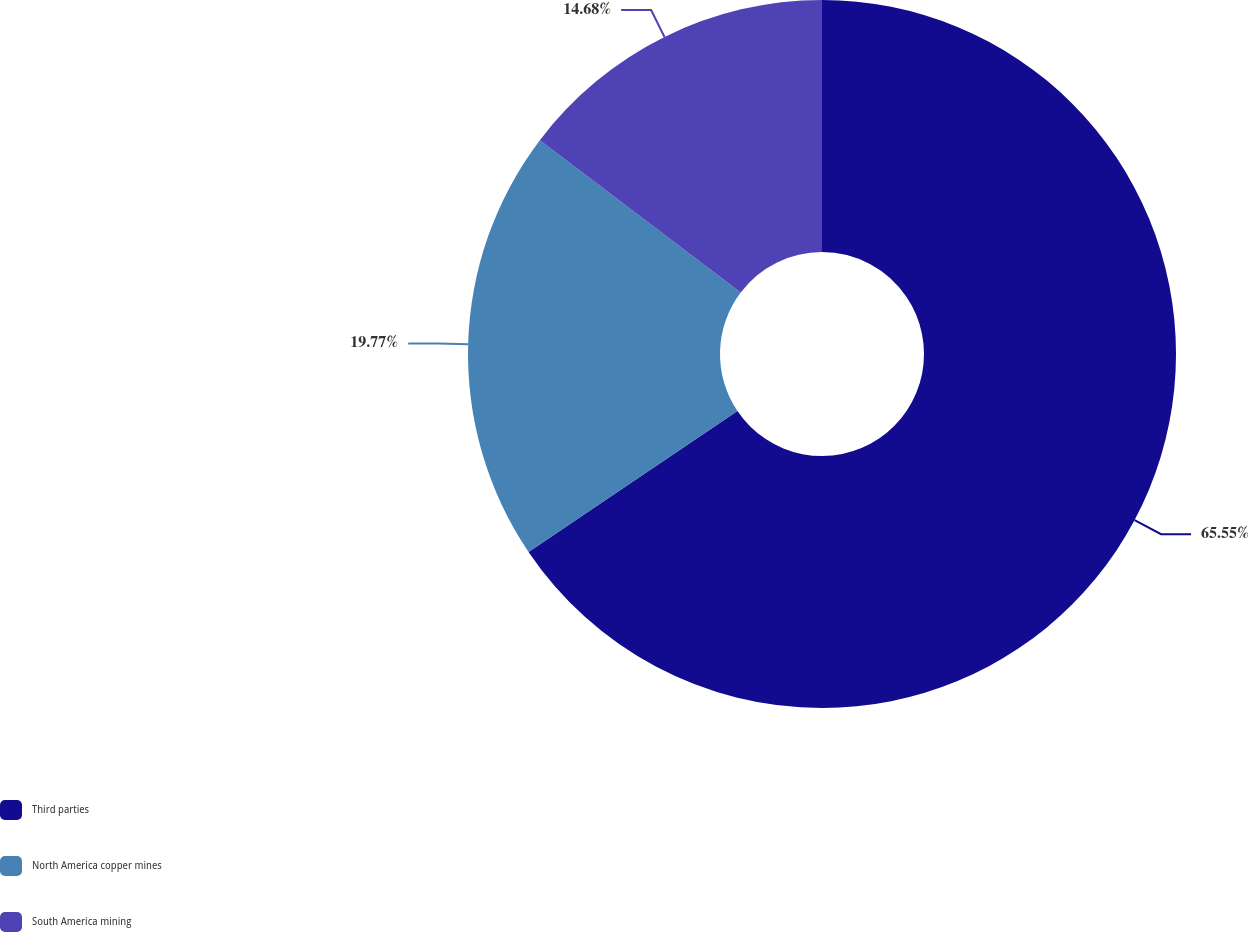Convert chart to OTSL. <chart><loc_0><loc_0><loc_500><loc_500><pie_chart><fcel>Third parties<fcel>North America copper mines<fcel>South America mining<nl><fcel>65.56%<fcel>19.77%<fcel>14.68%<nl></chart> 